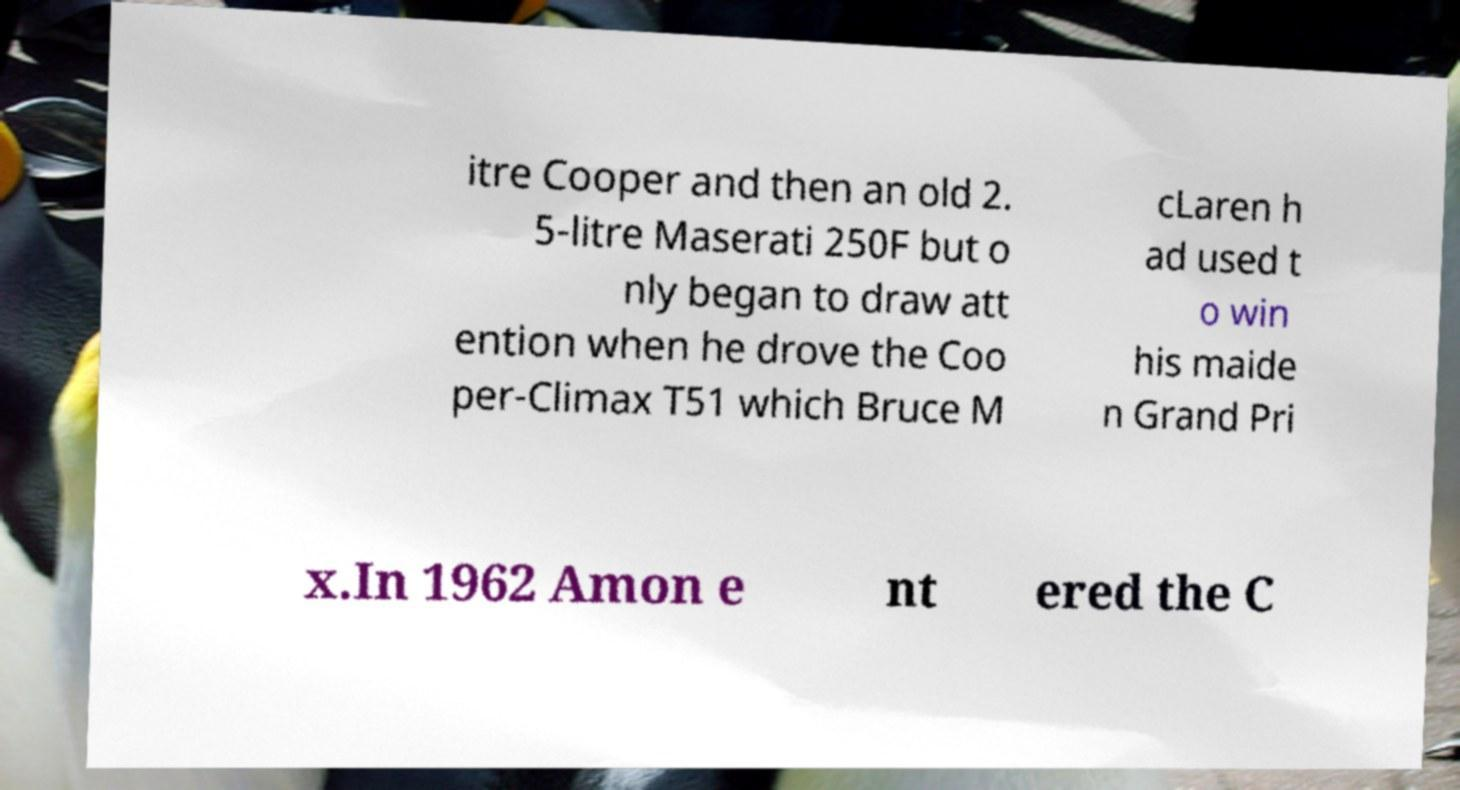Please identify and transcribe the text found in this image. itre Cooper and then an old 2. 5-litre Maserati 250F but o nly began to draw att ention when he drove the Coo per-Climax T51 which Bruce M cLaren h ad used t o win his maide n Grand Pri x.In 1962 Amon e nt ered the C 